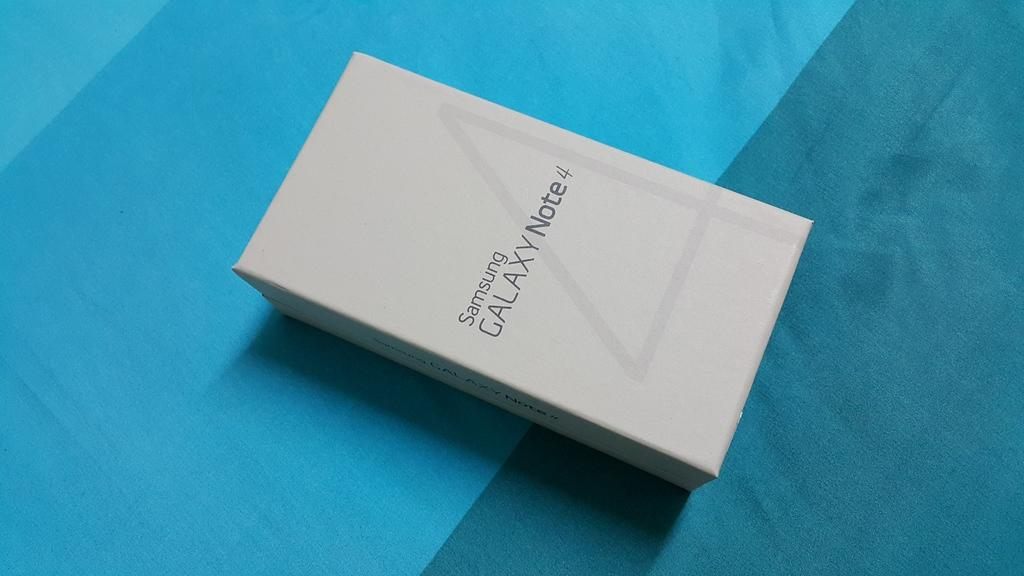<image>
Summarize the visual content of the image. White box with Samsung Galaxy Note 4 written on top of the box. 